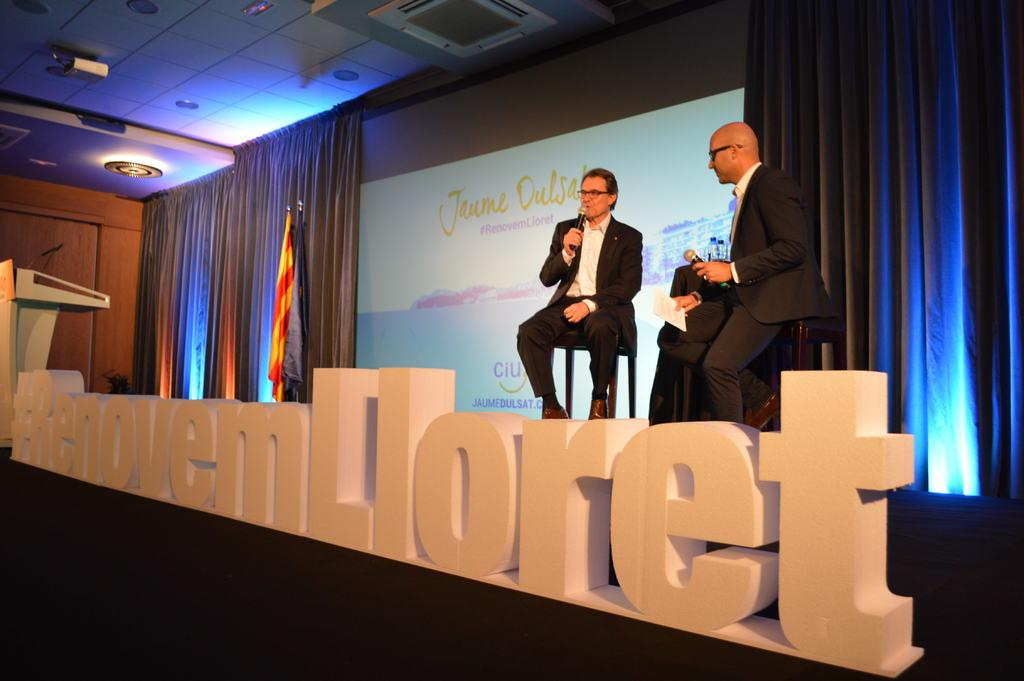<image>
Render a clear and concise summary of the photo. Large letters in white spell renovemlloret in front of the stage. 